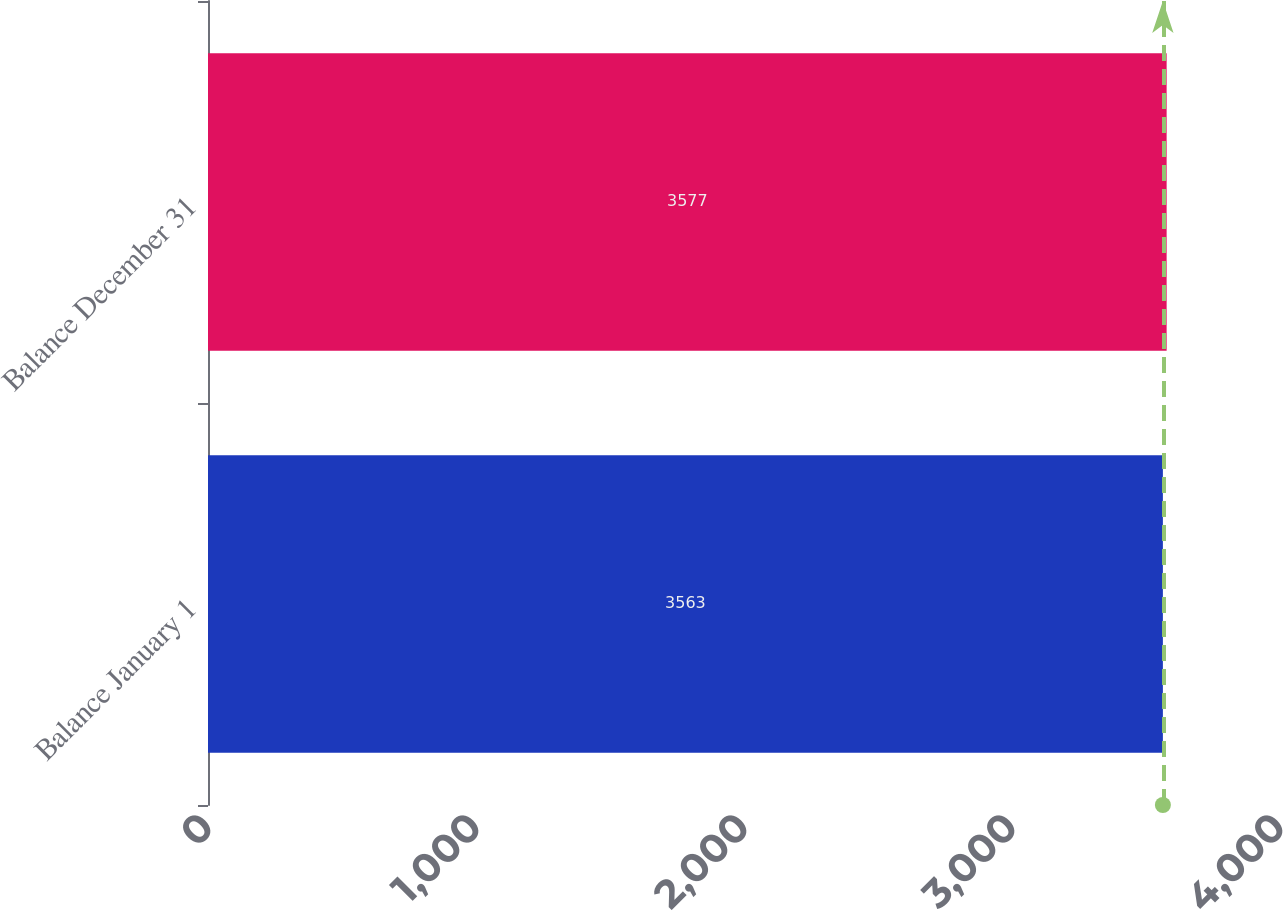Convert chart. <chart><loc_0><loc_0><loc_500><loc_500><bar_chart><fcel>Balance January 1<fcel>Balance December 31<nl><fcel>3563<fcel>3577<nl></chart> 